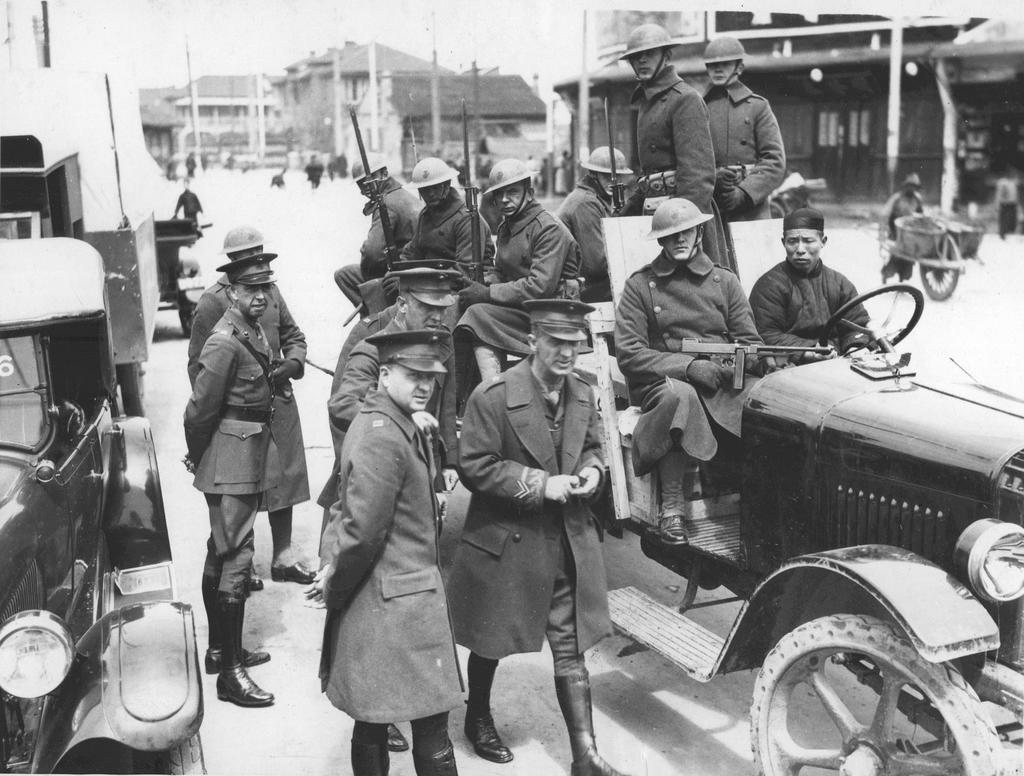Can you describe this image briefly? It is a black and white picture. In the center of the image we can see a few vehicles and a few people are standing and they are wearing caps and they are in different costumes. On the front vehicle, we can see two persons are standing and a few people are sitting and they are holding guns. And we can see they are wearing helmets and they are in different costumes. In the background we can see the sky, buildings, poles, one door, few people are standing, few people are holding some objects and a few other objects. 